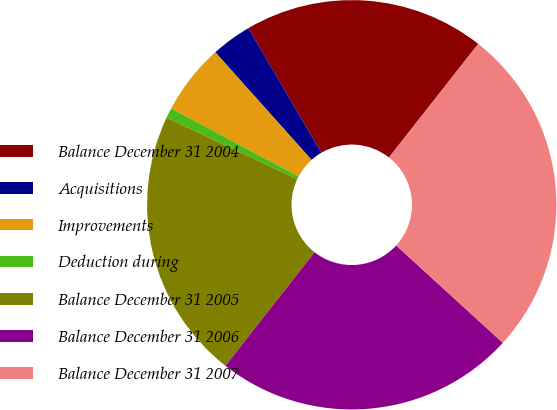Convert chart. <chart><loc_0><loc_0><loc_500><loc_500><pie_chart><fcel>Balance December 31 2004<fcel>Acquisitions<fcel>Improvements<fcel>Deduction during<fcel>Balance December 31 2005<fcel>Balance December 31 2006<fcel>Balance December 31 2007<nl><fcel>19.03%<fcel>3.19%<fcel>5.58%<fcel>0.81%<fcel>21.41%<fcel>23.8%<fcel>26.18%<nl></chart> 